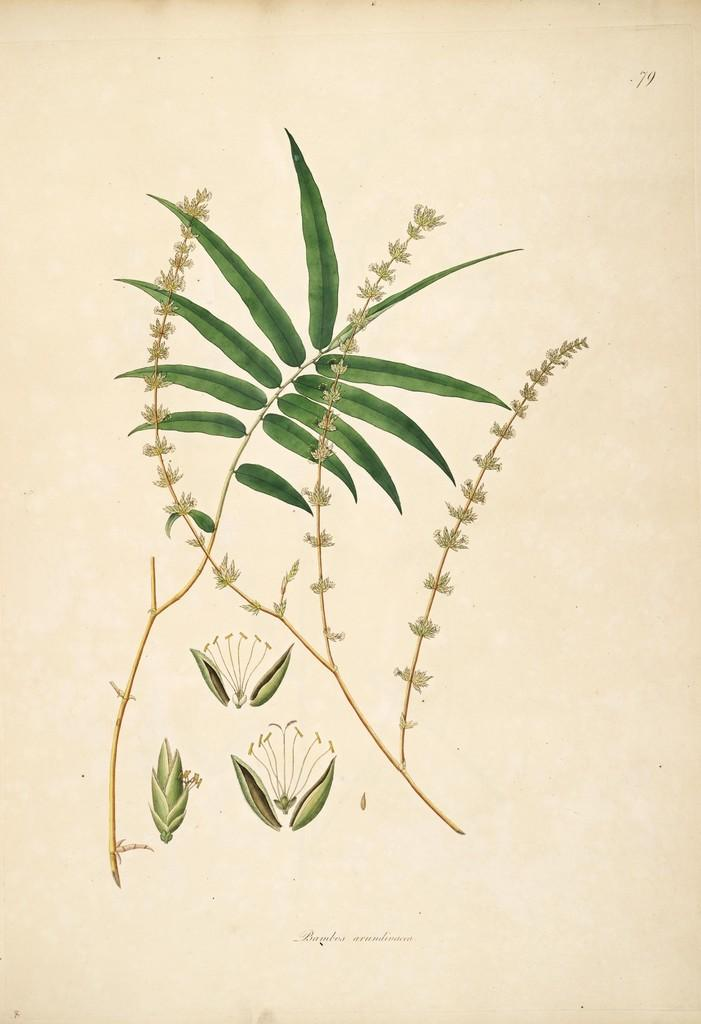What is the medium of the image? The picture is printed. What type of natural elements can be seen in the image? There are leaves depicted in the picture. What type of cherry is being used to hold the net in the image? There is no cherry or net present in the image; it only features leaves. What type of knife is being used to cut the leaves in the image? There is no knife present in the image, and the leaves are depicted as a static image. 